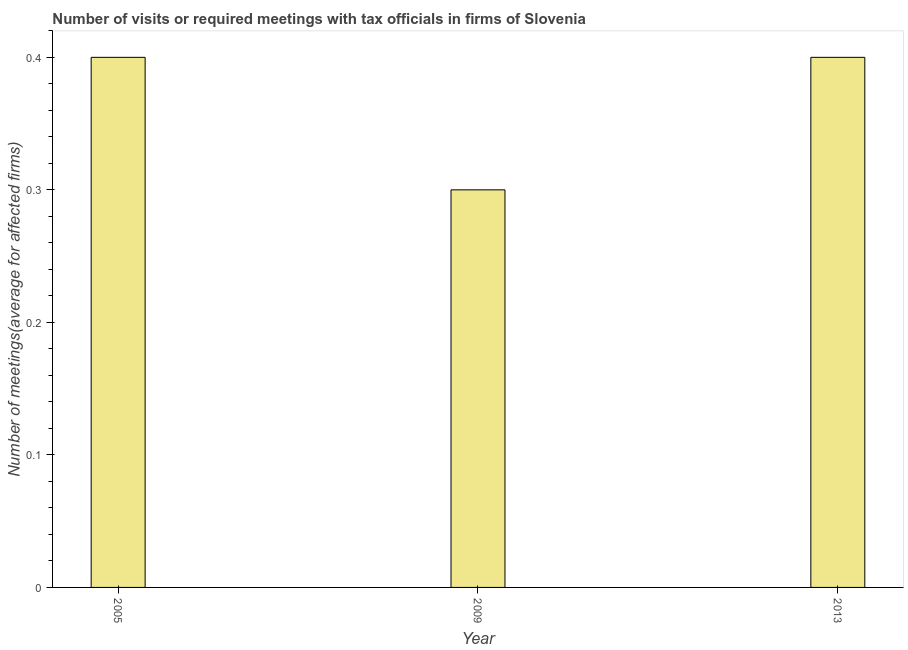What is the title of the graph?
Provide a succinct answer. Number of visits or required meetings with tax officials in firms of Slovenia. What is the label or title of the X-axis?
Offer a terse response. Year. What is the label or title of the Y-axis?
Your answer should be very brief. Number of meetings(average for affected firms). What is the number of required meetings with tax officials in 2013?
Give a very brief answer. 0.4. In which year was the number of required meetings with tax officials maximum?
Make the answer very short. 2005. In which year was the number of required meetings with tax officials minimum?
Keep it short and to the point. 2009. What is the average number of required meetings with tax officials per year?
Provide a short and direct response. 0.37. What is the median number of required meetings with tax officials?
Provide a succinct answer. 0.4. In how many years, is the number of required meetings with tax officials greater than 0.32 ?
Your response must be concise. 2. What is the ratio of the number of required meetings with tax officials in 2005 to that in 2009?
Offer a terse response. 1.33. What is the difference between the highest and the second highest number of required meetings with tax officials?
Your response must be concise. 0. Is the sum of the number of required meetings with tax officials in 2005 and 2013 greater than the maximum number of required meetings with tax officials across all years?
Ensure brevity in your answer.  Yes. In how many years, is the number of required meetings with tax officials greater than the average number of required meetings with tax officials taken over all years?
Give a very brief answer. 2. How many bars are there?
Your answer should be very brief. 3. Are all the bars in the graph horizontal?
Keep it short and to the point. No. How many years are there in the graph?
Provide a succinct answer. 3. What is the difference between two consecutive major ticks on the Y-axis?
Your response must be concise. 0.1. Are the values on the major ticks of Y-axis written in scientific E-notation?
Give a very brief answer. No. What is the Number of meetings(average for affected firms) of 2009?
Your answer should be very brief. 0.3. What is the difference between the Number of meetings(average for affected firms) in 2005 and 2009?
Your answer should be compact. 0.1. What is the difference between the Number of meetings(average for affected firms) in 2009 and 2013?
Keep it short and to the point. -0.1. What is the ratio of the Number of meetings(average for affected firms) in 2005 to that in 2009?
Offer a terse response. 1.33. What is the ratio of the Number of meetings(average for affected firms) in 2005 to that in 2013?
Your response must be concise. 1. 